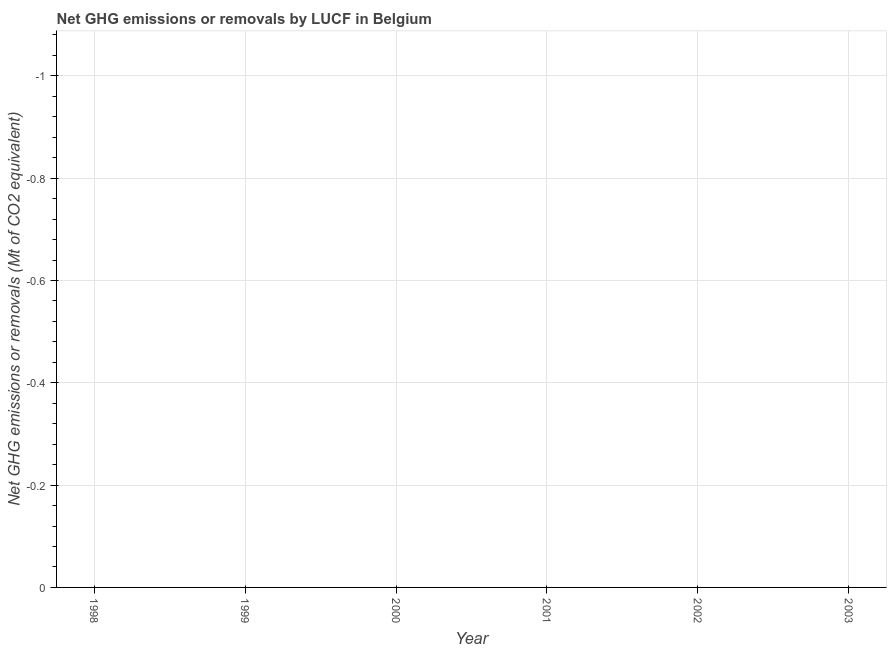What is the sum of the ghg net emissions or removals?
Make the answer very short. 0. In how many years, is the ghg net emissions or removals greater than -0.88 Mt?
Offer a terse response. 0. In how many years, is the ghg net emissions or removals greater than the average ghg net emissions or removals taken over all years?
Your answer should be very brief. 0. Does the ghg net emissions or removals monotonically increase over the years?
Make the answer very short. No. What is the difference between two consecutive major ticks on the Y-axis?
Your response must be concise. 0.2. Are the values on the major ticks of Y-axis written in scientific E-notation?
Provide a short and direct response. No. What is the title of the graph?
Your answer should be compact. Net GHG emissions or removals by LUCF in Belgium. What is the label or title of the Y-axis?
Make the answer very short. Net GHG emissions or removals (Mt of CO2 equivalent). What is the Net GHG emissions or removals (Mt of CO2 equivalent) of 1998?
Give a very brief answer. 0. What is the Net GHG emissions or removals (Mt of CO2 equivalent) in 1999?
Make the answer very short. 0. What is the Net GHG emissions or removals (Mt of CO2 equivalent) in 2001?
Ensure brevity in your answer.  0. What is the Net GHG emissions or removals (Mt of CO2 equivalent) of 2002?
Offer a very short reply. 0. 